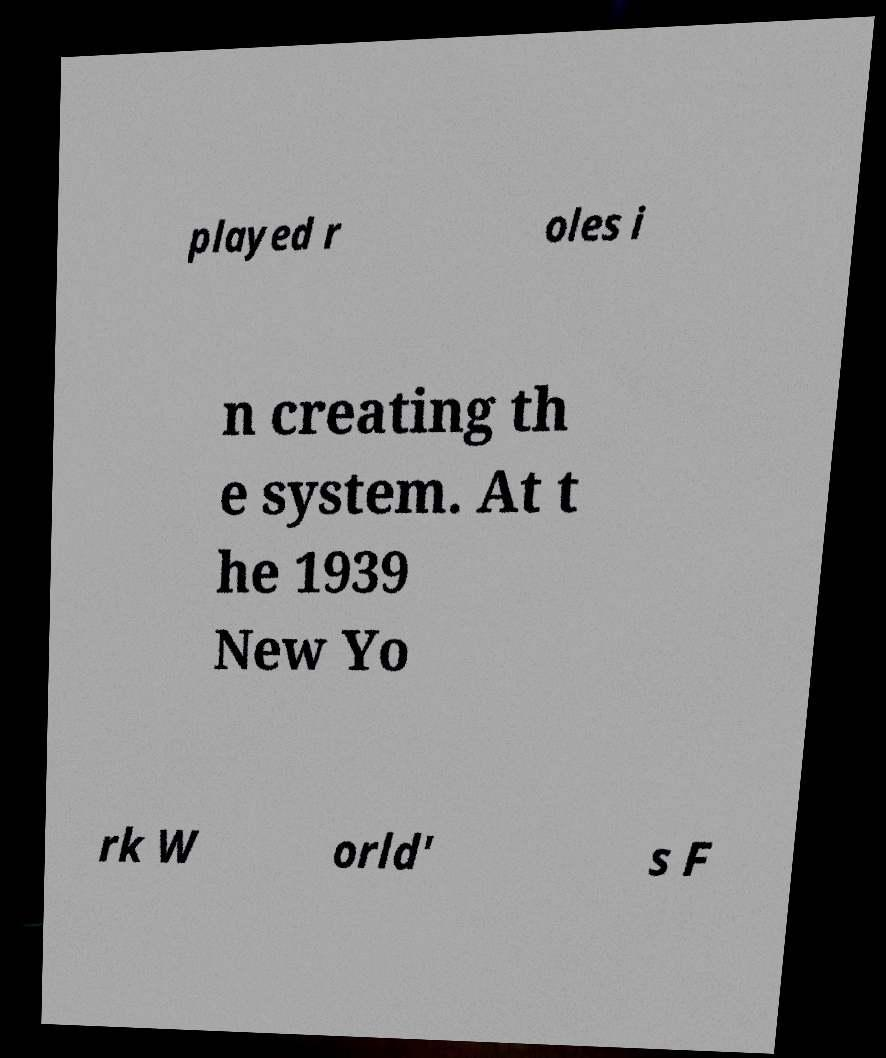What messages or text are displayed in this image? I need them in a readable, typed format. played r oles i n creating th e system. At t he 1939 New Yo rk W orld' s F 